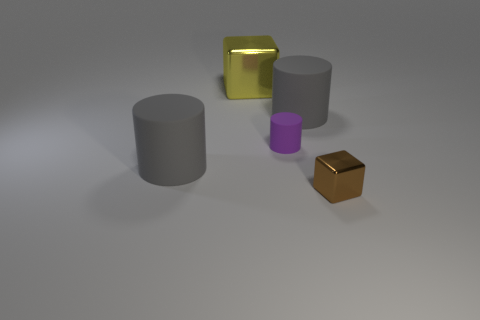There is a large object that is in front of the big yellow metal cube and to the left of the tiny cylinder; what is its color?
Give a very brief answer. Gray. Are there more gray matte things that are to the right of the tiny matte cylinder than tiny cylinders on the left side of the big yellow block?
Offer a very short reply. Yes. There is another cube that is the same material as the small brown block; what is its size?
Offer a terse response. Large. How many brown cubes are on the left side of the tiny metal object that is right of the yellow metallic block?
Provide a short and direct response. 0. Are there any tiny cyan matte things of the same shape as the tiny shiny thing?
Provide a succinct answer. No. What is the color of the shiny thing left of the shiny thing in front of the large yellow object?
Make the answer very short. Yellow. Is the number of small gray rubber balls greater than the number of gray matte objects?
Provide a short and direct response. No. How many cylinders are the same size as the yellow metallic block?
Make the answer very short. 2. Are the big yellow thing and the small object that is behind the small brown metal block made of the same material?
Ensure brevity in your answer.  No. Are there fewer objects than brown metallic things?
Give a very brief answer. No. 